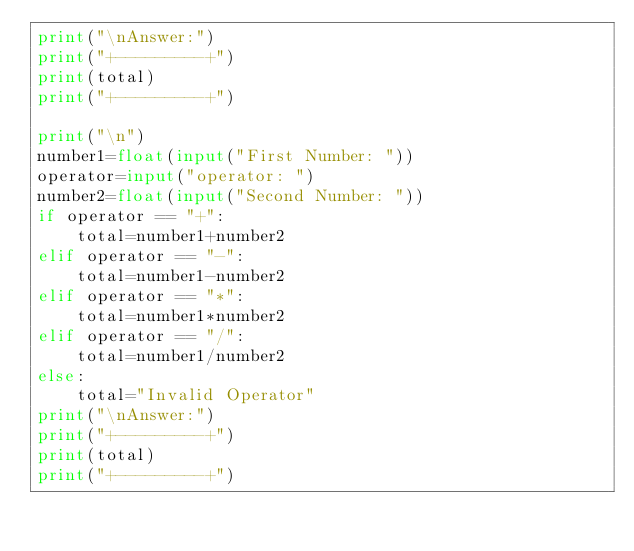<code> <loc_0><loc_0><loc_500><loc_500><_Python_>print("\nAnswer:")
print("+---------+")
print(total)
print("+---------+")

print("\n")
number1=float(input("First Number: "))
operator=input("operator: ")
number2=float(input("Second Number: "))
if operator == "+":
    total=number1+number2
elif operator == "-":
    total=number1-number2
elif operator == "*":
    total=number1*number2
elif operator == "/":
    total=number1/number2
else:
    total="Invalid Operator"
print("\nAnswer:")
print("+---------+")
print(total)
print("+---------+")</code> 